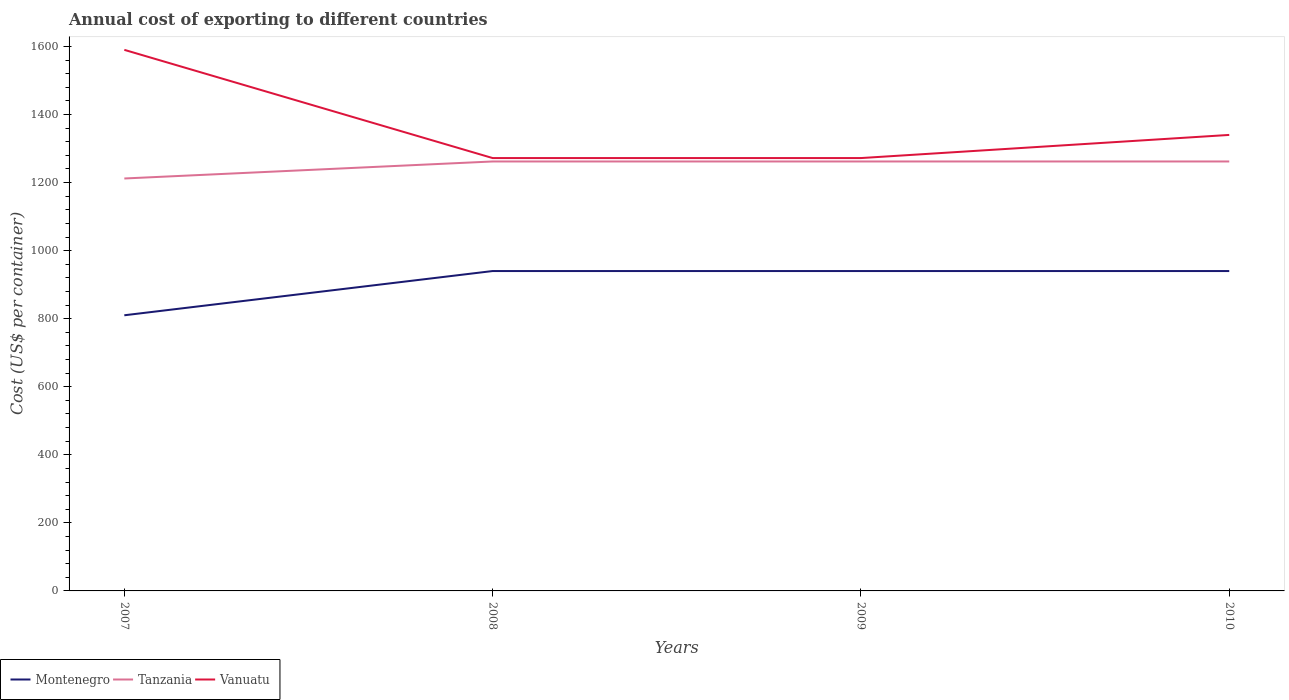Does the line corresponding to Montenegro intersect with the line corresponding to Vanuatu?
Offer a terse response. No. Is the number of lines equal to the number of legend labels?
Ensure brevity in your answer.  Yes. Across all years, what is the maximum total annual cost of exporting in Vanuatu?
Your answer should be compact. 1272. In which year was the total annual cost of exporting in Montenegro maximum?
Offer a terse response. 2007. What is the difference between the highest and the second highest total annual cost of exporting in Montenegro?
Ensure brevity in your answer.  130. What is the difference between the highest and the lowest total annual cost of exporting in Tanzania?
Give a very brief answer. 3. Does the graph contain any zero values?
Provide a succinct answer. No. Does the graph contain grids?
Make the answer very short. No. Where does the legend appear in the graph?
Your answer should be very brief. Bottom left. How many legend labels are there?
Ensure brevity in your answer.  3. How are the legend labels stacked?
Keep it short and to the point. Horizontal. What is the title of the graph?
Make the answer very short. Annual cost of exporting to different countries. Does "Europe(all income levels)" appear as one of the legend labels in the graph?
Your response must be concise. No. What is the label or title of the X-axis?
Offer a very short reply. Years. What is the label or title of the Y-axis?
Your answer should be compact. Cost (US$ per container). What is the Cost (US$ per container) of Montenegro in 2007?
Your answer should be very brief. 810. What is the Cost (US$ per container) of Tanzania in 2007?
Your response must be concise. 1212. What is the Cost (US$ per container) of Vanuatu in 2007?
Provide a short and direct response. 1590. What is the Cost (US$ per container) in Montenegro in 2008?
Provide a short and direct response. 940. What is the Cost (US$ per container) in Tanzania in 2008?
Your answer should be compact. 1262. What is the Cost (US$ per container) of Vanuatu in 2008?
Your answer should be very brief. 1272. What is the Cost (US$ per container) of Montenegro in 2009?
Provide a short and direct response. 940. What is the Cost (US$ per container) in Tanzania in 2009?
Provide a short and direct response. 1262. What is the Cost (US$ per container) in Vanuatu in 2009?
Offer a terse response. 1272. What is the Cost (US$ per container) of Montenegro in 2010?
Your answer should be compact. 940. What is the Cost (US$ per container) in Tanzania in 2010?
Make the answer very short. 1262. What is the Cost (US$ per container) of Vanuatu in 2010?
Offer a very short reply. 1340. Across all years, what is the maximum Cost (US$ per container) of Montenegro?
Your answer should be very brief. 940. Across all years, what is the maximum Cost (US$ per container) in Tanzania?
Provide a succinct answer. 1262. Across all years, what is the maximum Cost (US$ per container) of Vanuatu?
Give a very brief answer. 1590. Across all years, what is the minimum Cost (US$ per container) in Montenegro?
Provide a succinct answer. 810. Across all years, what is the minimum Cost (US$ per container) of Tanzania?
Your response must be concise. 1212. Across all years, what is the minimum Cost (US$ per container) in Vanuatu?
Ensure brevity in your answer.  1272. What is the total Cost (US$ per container) in Montenegro in the graph?
Your answer should be very brief. 3630. What is the total Cost (US$ per container) in Tanzania in the graph?
Offer a very short reply. 4998. What is the total Cost (US$ per container) in Vanuatu in the graph?
Your answer should be compact. 5474. What is the difference between the Cost (US$ per container) of Montenegro in 2007 and that in 2008?
Give a very brief answer. -130. What is the difference between the Cost (US$ per container) of Tanzania in 2007 and that in 2008?
Give a very brief answer. -50. What is the difference between the Cost (US$ per container) in Vanuatu in 2007 and that in 2008?
Provide a succinct answer. 318. What is the difference between the Cost (US$ per container) in Montenegro in 2007 and that in 2009?
Keep it short and to the point. -130. What is the difference between the Cost (US$ per container) of Tanzania in 2007 and that in 2009?
Offer a very short reply. -50. What is the difference between the Cost (US$ per container) of Vanuatu in 2007 and that in 2009?
Ensure brevity in your answer.  318. What is the difference between the Cost (US$ per container) in Montenegro in 2007 and that in 2010?
Your answer should be compact. -130. What is the difference between the Cost (US$ per container) in Tanzania in 2007 and that in 2010?
Make the answer very short. -50. What is the difference between the Cost (US$ per container) of Vanuatu in 2007 and that in 2010?
Ensure brevity in your answer.  250. What is the difference between the Cost (US$ per container) of Montenegro in 2008 and that in 2009?
Provide a short and direct response. 0. What is the difference between the Cost (US$ per container) in Tanzania in 2008 and that in 2009?
Offer a very short reply. 0. What is the difference between the Cost (US$ per container) in Vanuatu in 2008 and that in 2009?
Your response must be concise. 0. What is the difference between the Cost (US$ per container) of Vanuatu in 2008 and that in 2010?
Give a very brief answer. -68. What is the difference between the Cost (US$ per container) of Montenegro in 2009 and that in 2010?
Your response must be concise. 0. What is the difference between the Cost (US$ per container) in Vanuatu in 2009 and that in 2010?
Offer a terse response. -68. What is the difference between the Cost (US$ per container) in Montenegro in 2007 and the Cost (US$ per container) in Tanzania in 2008?
Provide a succinct answer. -452. What is the difference between the Cost (US$ per container) in Montenegro in 2007 and the Cost (US$ per container) in Vanuatu in 2008?
Your answer should be compact. -462. What is the difference between the Cost (US$ per container) in Tanzania in 2007 and the Cost (US$ per container) in Vanuatu in 2008?
Ensure brevity in your answer.  -60. What is the difference between the Cost (US$ per container) of Montenegro in 2007 and the Cost (US$ per container) of Tanzania in 2009?
Offer a terse response. -452. What is the difference between the Cost (US$ per container) of Montenegro in 2007 and the Cost (US$ per container) of Vanuatu in 2009?
Your answer should be very brief. -462. What is the difference between the Cost (US$ per container) in Tanzania in 2007 and the Cost (US$ per container) in Vanuatu in 2009?
Keep it short and to the point. -60. What is the difference between the Cost (US$ per container) of Montenegro in 2007 and the Cost (US$ per container) of Tanzania in 2010?
Give a very brief answer. -452. What is the difference between the Cost (US$ per container) in Montenegro in 2007 and the Cost (US$ per container) in Vanuatu in 2010?
Your answer should be compact. -530. What is the difference between the Cost (US$ per container) of Tanzania in 2007 and the Cost (US$ per container) of Vanuatu in 2010?
Make the answer very short. -128. What is the difference between the Cost (US$ per container) in Montenegro in 2008 and the Cost (US$ per container) in Tanzania in 2009?
Your answer should be very brief. -322. What is the difference between the Cost (US$ per container) in Montenegro in 2008 and the Cost (US$ per container) in Vanuatu in 2009?
Your answer should be compact. -332. What is the difference between the Cost (US$ per container) in Tanzania in 2008 and the Cost (US$ per container) in Vanuatu in 2009?
Keep it short and to the point. -10. What is the difference between the Cost (US$ per container) in Montenegro in 2008 and the Cost (US$ per container) in Tanzania in 2010?
Your answer should be very brief. -322. What is the difference between the Cost (US$ per container) in Montenegro in 2008 and the Cost (US$ per container) in Vanuatu in 2010?
Your answer should be compact. -400. What is the difference between the Cost (US$ per container) of Tanzania in 2008 and the Cost (US$ per container) of Vanuatu in 2010?
Ensure brevity in your answer.  -78. What is the difference between the Cost (US$ per container) of Montenegro in 2009 and the Cost (US$ per container) of Tanzania in 2010?
Provide a short and direct response. -322. What is the difference between the Cost (US$ per container) in Montenegro in 2009 and the Cost (US$ per container) in Vanuatu in 2010?
Keep it short and to the point. -400. What is the difference between the Cost (US$ per container) of Tanzania in 2009 and the Cost (US$ per container) of Vanuatu in 2010?
Ensure brevity in your answer.  -78. What is the average Cost (US$ per container) of Montenegro per year?
Provide a succinct answer. 907.5. What is the average Cost (US$ per container) in Tanzania per year?
Make the answer very short. 1249.5. What is the average Cost (US$ per container) of Vanuatu per year?
Provide a succinct answer. 1368.5. In the year 2007, what is the difference between the Cost (US$ per container) in Montenegro and Cost (US$ per container) in Tanzania?
Your response must be concise. -402. In the year 2007, what is the difference between the Cost (US$ per container) of Montenegro and Cost (US$ per container) of Vanuatu?
Make the answer very short. -780. In the year 2007, what is the difference between the Cost (US$ per container) in Tanzania and Cost (US$ per container) in Vanuatu?
Ensure brevity in your answer.  -378. In the year 2008, what is the difference between the Cost (US$ per container) in Montenegro and Cost (US$ per container) in Tanzania?
Give a very brief answer. -322. In the year 2008, what is the difference between the Cost (US$ per container) in Montenegro and Cost (US$ per container) in Vanuatu?
Your answer should be compact. -332. In the year 2008, what is the difference between the Cost (US$ per container) of Tanzania and Cost (US$ per container) of Vanuatu?
Offer a terse response. -10. In the year 2009, what is the difference between the Cost (US$ per container) in Montenegro and Cost (US$ per container) in Tanzania?
Provide a short and direct response. -322. In the year 2009, what is the difference between the Cost (US$ per container) of Montenegro and Cost (US$ per container) of Vanuatu?
Give a very brief answer. -332. In the year 2009, what is the difference between the Cost (US$ per container) in Tanzania and Cost (US$ per container) in Vanuatu?
Your answer should be compact. -10. In the year 2010, what is the difference between the Cost (US$ per container) of Montenegro and Cost (US$ per container) of Tanzania?
Your answer should be compact. -322. In the year 2010, what is the difference between the Cost (US$ per container) of Montenegro and Cost (US$ per container) of Vanuatu?
Provide a short and direct response. -400. In the year 2010, what is the difference between the Cost (US$ per container) of Tanzania and Cost (US$ per container) of Vanuatu?
Make the answer very short. -78. What is the ratio of the Cost (US$ per container) of Montenegro in 2007 to that in 2008?
Provide a short and direct response. 0.86. What is the ratio of the Cost (US$ per container) of Tanzania in 2007 to that in 2008?
Your response must be concise. 0.96. What is the ratio of the Cost (US$ per container) in Vanuatu in 2007 to that in 2008?
Offer a very short reply. 1.25. What is the ratio of the Cost (US$ per container) of Montenegro in 2007 to that in 2009?
Your response must be concise. 0.86. What is the ratio of the Cost (US$ per container) of Tanzania in 2007 to that in 2009?
Provide a short and direct response. 0.96. What is the ratio of the Cost (US$ per container) in Montenegro in 2007 to that in 2010?
Your response must be concise. 0.86. What is the ratio of the Cost (US$ per container) in Tanzania in 2007 to that in 2010?
Make the answer very short. 0.96. What is the ratio of the Cost (US$ per container) of Vanuatu in 2007 to that in 2010?
Provide a succinct answer. 1.19. What is the ratio of the Cost (US$ per container) in Montenegro in 2008 to that in 2009?
Make the answer very short. 1. What is the ratio of the Cost (US$ per container) in Tanzania in 2008 to that in 2009?
Offer a terse response. 1. What is the ratio of the Cost (US$ per container) of Montenegro in 2008 to that in 2010?
Give a very brief answer. 1. What is the ratio of the Cost (US$ per container) of Vanuatu in 2008 to that in 2010?
Your response must be concise. 0.95. What is the ratio of the Cost (US$ per container) in Montenegro in 2009 to that in 2010?
Your response must be concise. 1. What is the ratio of the Cost (US$ per container) in Tanzania in 2009 to that in 2010?
Offer a terse response. 1. What is the ratio of the Cost (US$ per container) in Vanuatu in 2009 to that in 2010?
Your answer should be compact. 0.95. What is the difference between the highest and the second highest Cost (US$ per container) of Montenegro?
Your answer should be compact. 0. What is the difference between the highest and the second highest Cost (US$ per container) in Vanuatu?
Keep it short and to the point. 250. What is the difference between the highest and the lowest Cost (US$ per container) of Montenegro?
Give a very brief answer. 130. What is the difference between the highest and the lowest Cost (US$ per container) of Tanzania?
Offer a terse response. 50. What is the difference between the highest and the lowest Cost (US$ per container) in Vanuatu?
Give a very brief answer. 318. 